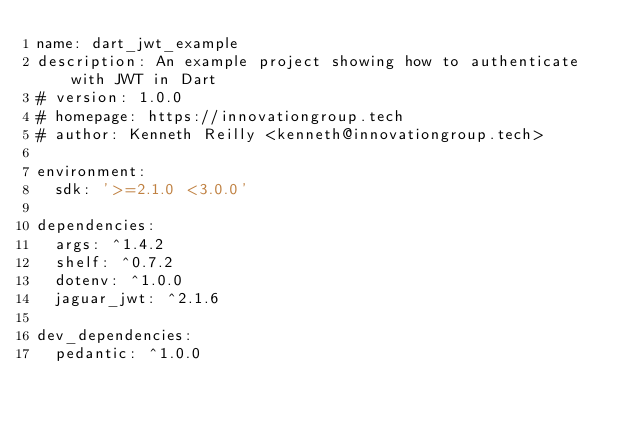<code> <loc_0><loc_0><loc_500><loc_500><_YAML_>name: dart_jwt_example
description: An example project showing how to authenticate with JWT in Dart
# version: 1.0.0
# homepage: https://innovationgroup.tech
# author: Kenneth Reilly <kenneth@innovationgroup.tech>

environment:
  sdk: '>=2.1.0 <3.0.0'

dependencies:
  args: ^1.4.2
  shelf: ^0.7.2
  dotenv: ^1.0.0
  jaguar_jwt: ^2.1.6

dev_dependencies:
  pedantic: ^1.0.0
</code> 